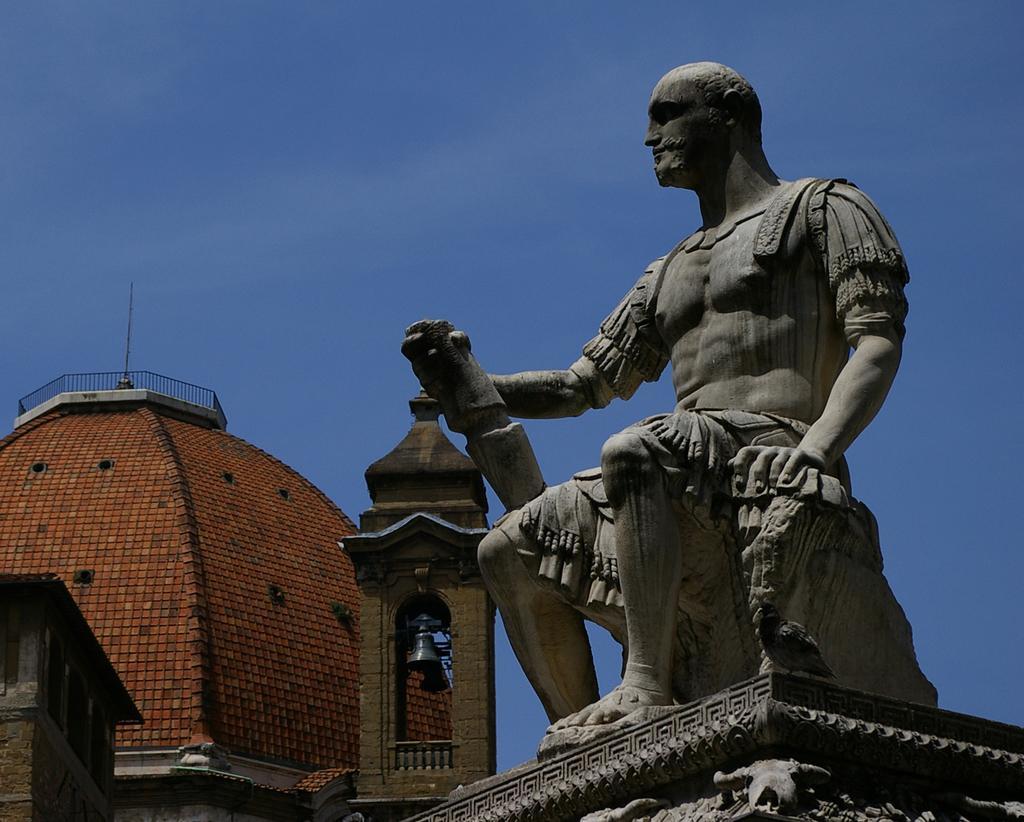Please provide a concise description of this image. There is a statue of a person sitting. In the back there is a building with railing. Also there is a bell. In the background there is sky. 